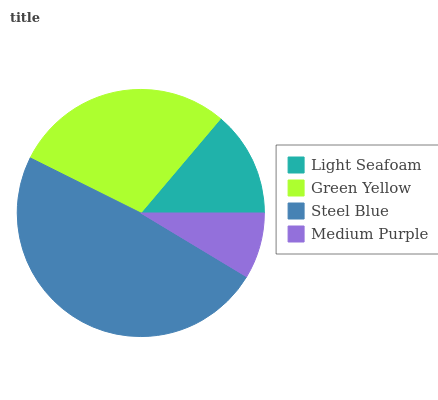Is Medium Purple the minimum?
Answer yes or no. Yes. Is Steel Blue the maximum?
Answer yes or no. Yes. Is Green Yellow the minimum?
Answer yes or no. No. Is Green Yellow the maximum?
Answer yes or no. No. Is Green Yellow greater than Light Seafoam?
Answer yes or no. Yes. Is Light Seafoam less than Green Yellow?
Answer yes or no. Yes. Is Light Seafoam greater than Green Yellow?
Answer yes or no. No. Is Green Yellow less than Light Seafoam?
Answer yes or no. No. Is Green Yellow the high median?
Answer yes or no. Yes. Is Light Seafoam the low median?
Answer yes or no. Yes. Is Steel Blue the high median?
Answer yes or no. No. Is Steel Blue the low median?
Answer yes or no. No. 